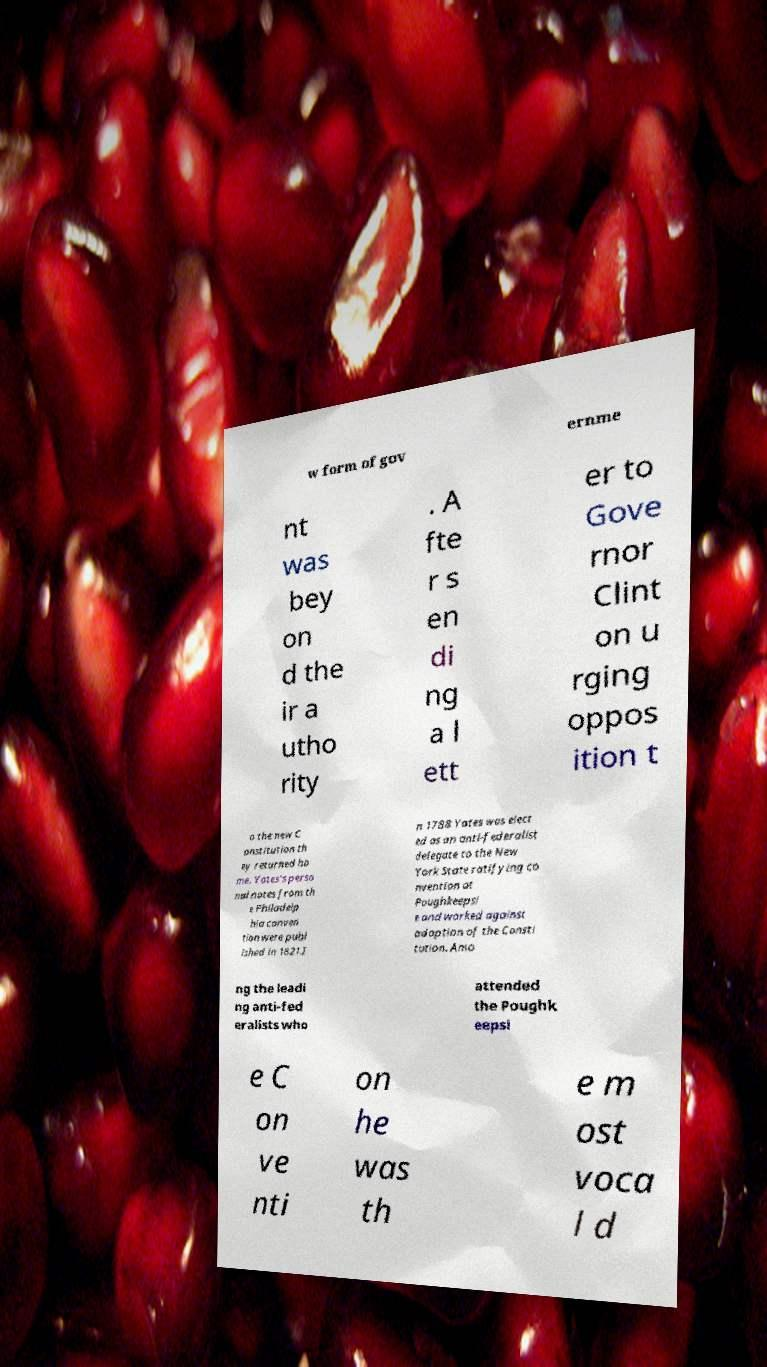What messages or text are displayed in this image? I need them in a readable, typed format. w form of gov ernme nt was bey on d the ir a utho rity . A fte r s en di ng a l ett er to Gove rnor Clint on u rging oppos ition t o the new C onstitution th ey returned ho me. Yates's perso nal notes from th e Philadelp hia conven tion were publ ished in 1821.I n 1788 Yates was elect ed as an anti-federalist delegate to the New York State ratifying co nvention at Poughkeepsi e and worked against adoption of the Consti tution. Amo ng the leadi ng anti-fed eralists who attended the Poughk eepsi e C on ve nti on he was th e m ost voca l d 